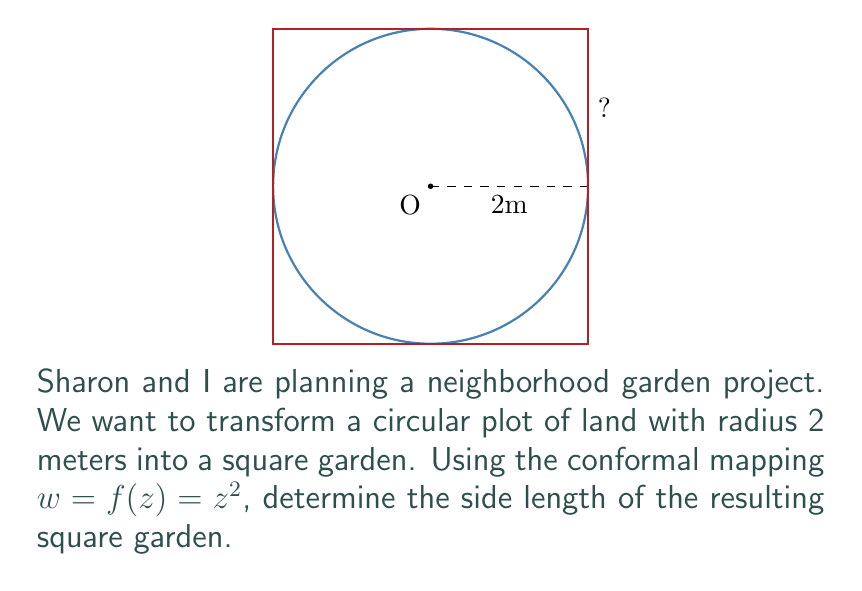Can you solve this math problem? Let's approach this step-by-step:

1) The given conformal mapping is $w = f(z) = z^2$.

2) In the z-plane, we have a circle with radius 2 centered at the origin. This can be described as $|z| = 2$.

3) To find the image of this circle under the mapping $w = z^2$, we need to consider what happens to the points on the circle:

   $w = z^2 = (2e^{i\theta})^2 = 4e^{2i\theta}$, where $0 \leq \theta < 2\pi$

4) This means that in the w-plane:
   - The magnitude of w is always 4: $|w| = 4$
   - The argument of w goes from 0 to $4\pi$

5) When we double the argument, we cover the full circle twice. This means our image will cover a full square in the w-plane.

6) The corners of this square will occur when $2\theta = 0, \frac{\pi}{2}, \pi, \frac{3\pi}{2}$

7) These corners are at $w = 4, 4i, -4, -4i$ respectively.

8) Therefore, the square has vertices at (4,0), (0,4), (-4,0), and (0,-4).

9) The side length of this square is the distance between any two adjacent vertices, which is 4$\sqrt{2}$ meters.
Answer: $4\sqrt{2}$ meters 